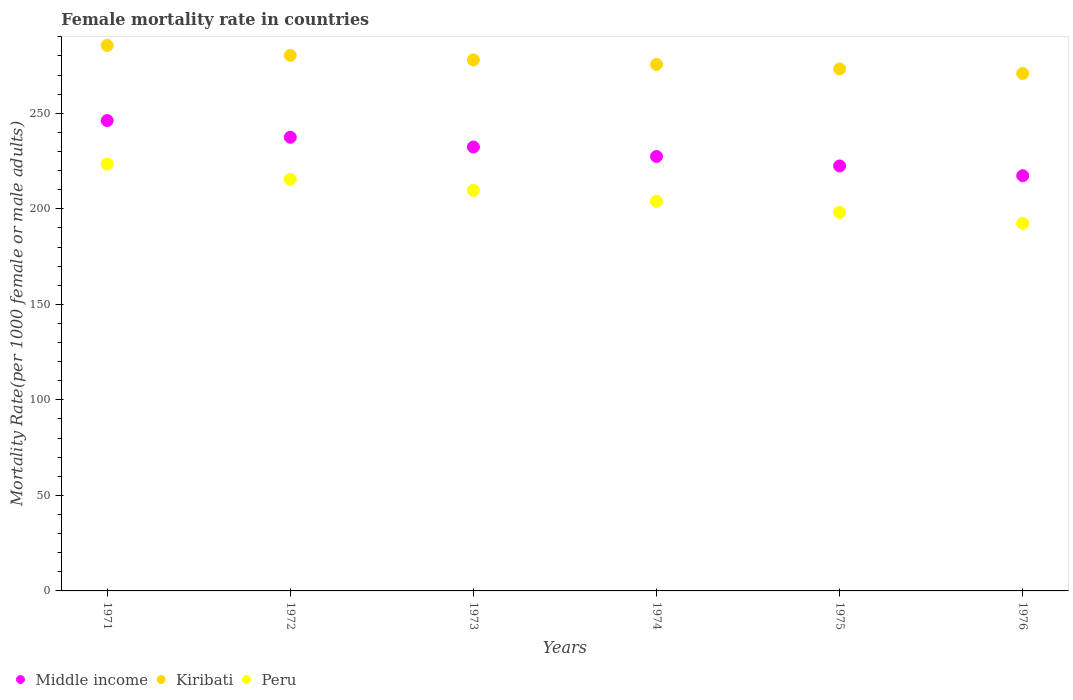How many different coloured dotlines are there?
Your answer should be very brief. 3. Is the number of dotlines equal to the number of legend labels?
Offer a very short reply. Yes. What is the female mortality rate in Peru in 1973?
Keep it short and to the point. 209.66. Across all years, what is the maximum female mortality rate in Kiribati?
Your response must be concise. 285.48. Across all years, what is the minimum female mortality rate in Kiribati?
Make the answer very short. 270.85. In which year was the female mortality rate in Kiribati maximum?
Ensure brevity in your answer.  1971. In which year was the female mortality rate in Peru minimum?
Offer a terse response. 1976. What is the total female mortality rate in Peru in the graph?
Your answer should be very brief. 1242.86. What is the difference between the female mortality rate in Middle income in 1974 and that in 1975?
Give a very brief answer. 4.95. What is the difference between the female mortality rate in Kiribati in 1973 and the female mortality rate in Middle income in 1974?
Make the answer very short. 50.55. What is the average female mortality rate in Kiribati per year?
Make the answer very short. 277.22. In the year 1974, what is the difference between the female mortality rate in Peru and female mortality rate in Middle income?
Provide a succinct answer. -23.49. What is the ratio of the female mortality rate in Kiribati in 1971 to that in 1974?
Your answer should be very brief. 1.04. What is the difference between the highest and the second highest female mortality rate in Kiribati?
Your response must be concise. 5.2. What is the difference between the highest and the lowest female mortality rate in Kiribati?
Offer a terse response. 14.63. In how many years, is the female mortality rate in Middle income greater than the average female mortality rate in Middle income taken over all years?
Provide a short and direct response. 3. Is it the case that in every year, the sum of the female mortality rate in Kiribati and female mortality rate in Middle income  is greater than the female mortality rate in Peru?
Make the answer very short. Yes. How many years are there in the graph?
Make the answer very short. 6. What is the difference between two consecutive major ticks on the Y-axis?
Ensure brevity in your answer.  50. Does the graph contain grids?
Give a very brief answer. No. Where does the legend appear in the graph?
Provide a short and direct response. Bottom left. How are the legend labels stacked?
Your response must be concise. Horizontal. What is the title of the graph?
Offer a very short reply. Female mortality rate in countries. Does "Mauritania" appear as one of the legend labels in the graph?
Keep it short and to the point. No. What is the label or title of the X-axis?
Offer a terse response. Years. What is the label or title of the Y-axis?
Offer a very short reply. Mortality Rate(per 1000 female or male adults). What is the Mortality Rate(per 1000 female or male adults) in Middle income in 1971?
Keep it short and to the point. 246.17. What is the Mortality Rate(per 1000 female or male adults) in Kiribati in 1971?
Your answer should be very brief. 285.48. What is the Mortality Rate(per 1000 female or male adults) of Peru in 1971?
Your answer should be very brief. 223.4. What is the Mortality Rate(per 1000 female or male adults) in Middle income in 1972?
Provide a short and direct response. 237.44. What is the Mortality Rate(per 1000 female or male adults) of Kiribati in 1972?
Make the answer very short. 280.28. What is the Mortality Rate(per 1000 female or male adults) of Peru in 1972?
Give a very brief answer. 215.43. What is the Mortality Rate(per 1000 female or male adults) in Middle income in 1973?
Give a very brief answer. 232.35. What is the Mortality Rate(per 1000 female or male adults) of Kiribati in 1973?
Your answer should be very brief. 277.92. What is the Mortality Rate(per 1000 female or male adults) in Peru in 1973?
Provide a short and direct response. 209.66. What is the Mortality Rate(per 1000 female or male adults) in Middle income in 1974?
Keep it short and to the point. 227.38. What is the Mortality Rate(per 1000 female or male adults) of Kiribati in 1974?
Provide a succinct answer. 275.56. What is the Mortality Rate(per 1000 female or male adults) of Peru in 1974?
Your answer should be very brief. 203.89. What is the Mortality Rate(per 1000 female or male adults) in Middle income in 1975?
Your answer should be compact. 222.43. What is the Mortality Rate(per 1000 female or male adults) in Kiribati in 1975?
Offer a very short reply. 273.21. What is the Mortality Rate(per 1000 female or male adults) of Peru in 1975?
Your response must be concise. 198.12. What is the Mortality Rate(per 1000 female or male adults) in Middle income in 1976?
Offer a terse response. 217.32. What is the Mortality Rate(per 1000 female or male adults) in Kiribati in 1976?
Your answer should be very brief. 270.85. What is the Mortality Rate(per 1000 female or male adults) of Peru in 1976?
Your answer should be very brief. 192.36. Across all years, what is the maximum Mortality Rate(per 1000 female or male adults) of Middle income?
Offer a very short reply. 246.17. Across all years, what is the maximum Mortality Rate(per 1000 female or male adults) of Kiribati?
Provide a succinct answer. 285.48. Across all years, what is the maximum Mortality Rate(per 1000 female or male adults) in Peru?
Offer a terse response. 223.4. Across all years, what is the minimum Mortality Rate(per 1000 female or male adults) in Middle income?
Offer a terse response. 217.32. Across all years, what is the minimum Mortality Rate(per 1000 female or male adults) in Kiribati?
Provide a succinct answer. 270.85. Across all years, what is the minimum Mortality Rate(per 1000 female or male adults) in Peru?
Provide a short and direct response. 192.36. What is the total Mortality Rate(per 1000 female or male adults) in Middle income in the graph?
Your answer should be compact. 1383.07. What is the total Mortality Rate(per 1000 female or male adults) of Kiribati in the graph?
Your answer should be very brief. 1663.3. What is the total Mortality Rate(per 1000 female or male adults) of Peru in the graph?
Ensure brevity in your answer.  1242.86. What is the difference between the Mortality Rate(per 1000 female or male adults) in Middle income in 1971 and that in 1972?
Make the answer very short. 8.73. What is the difference between the Mortality Rate(per 1000 female or male adults) in Kiribati in 1971 and that in 1972?
Your answer should be compact. 5.2. What is the difference between the Mortality Rate(per 1000 female or male adults) in Peru in 1971 and that in 1972?
Your answer should be very brief. 7.98. What is the difference between the Mortality Rate(per 1000 female or male adults) of Middle income in 1971 and that in 1973?
Ensure brevity in your answer.  13.82. What is the difference between the Mortality Rate(per 1000 female or male adults) of Kiribati in 1971 and that in 1973?
Make the answer very short. 7.56. What is the difference between the Mortality Rate(per 1000 female or male adults) in Peru in 1971 and that in 1973?
Offer a terse response. 13.74. What is the difference between the Mortality Rate(per 1000 female or male adults) in Middle income in 1971 and that in 1974?
Give a very brief answer. 18.79. What is the difference between the Mortality Rate(per 1000 female or male adults) in Kiribati in 1971 and that in 1974?
Offer a terse response. 9.91. What is the difference between the Mortality Rate(per 1000 female or male adults) in Peru in 1971 and that in 1974?
Provide a succinct answer. 19.51. What is the difference between the Mortality Rate(per 1000 female or male adults) in Middle income in 1971 and that in 1975?
Ensure brevity in your answer.  23.74. What is the difference between the Mortality Rate(per 1000 female or male adults) of Kiribati in 1971 and that in 1975?
Keep it short and to the point. 12.27. What is the difference between the Mortality Rate(per 1000 female or male adults) of Peru in 1971 and that in 1975?
Offer a very short reply. 25.28. What is the difference between the Mortality Rate(per 1000 female or male adults) in Middle income in 1971 and that in 1976?
Provide a succinct answer. 28.85. What is the difference between the Mortality Rate(per 1000 female or male adults) in Kiribati in 1971 and that in 1976?
Offer a very short reply. 14.63. What is the difference between the Mortality Rate(per 1000 female or male adults) of Peru in 1971 and that in 1976?
Provide a succinct answer. 31.05. What is the difference between the Mortality Rate(per 1000 female or male adults) of Middle income in 1972 and that in 1973?
Provide a succinct answer. 5.09. What is the difference between the Mortality Rate(per 1000 female or male adults) of Kiribati in 1972 and that in 1973?
Provide a short and direct response. 2.36. What is the difference between the Mortality Rate(per 1000 female or male adults) of Peru in 1972 and that in 1973?
Offer a terse response. 5.77. What is the difference between the Mortality Rate(per 1000 female or male adults) of Middle income in 1972 and that in 1974?
Keep it short and to the point. 10.06. What is the difference between the Mortality Rate(per 1000 female or male adults) in Kiribati in 1972 and that in 1974?
Keep it short and to the point. 4.72. What is the difference between the Mortality Rate(per 1000 female or male adults) in Peru in 1972 and that in 1974?
Your answer should be very brief. 11.54. What is the difference between the Mortality Rate(per 1000 female or male adults) of Middle income in 1972 and that in 1975?
Provide a short and direct response. 15.01. What is the difference between the Mortality Rate(per 1000 female or male adults) in Kiribati in 1972 and that in 1975?
Provide a succinct answer. 7.07. What is the difference between the Mortality Rate(per 1000 female or male adults) in Peru in 1972 and that in 1975?
Your response must be concise. 17.3. What is the difference between the Mortality Rate(per 1000 female or male adults) in Middle income in 1972 and that in 1976?
Provide a short and direct response. 20.12. What is the difference between the Mortality Rate(per 1000 female or male adults) of Kiribati in 1972 and that in 1976?
Your response must be concise. 9.43. What is the difference between the Mortality Rate(per 1000 female or male adults) in Peru in 1972 and that in 1976?
Offer a very short reply. 23.07. What is the difference between the Mortality Rate(per 1000 female or male adults) of Middle income in 1973 and that in 1974?
Provide a short and direct response. 4.97. What is the difference between the Mortality Rate(per 1000 female or male adults) in Kiribati in 1973 and that in 1974?
Your answer should be compact. 2.36. What is the difference between the Mortality Rate(per 1000 female or male adults) in Peru in 1973 and that in 1974?
Keep it short and to the point. 5.77. What is the difference between the Mortality Rate(per 1000 female or male adults) in Middle income in 1973 and that in 1975?
Make the answer very short. 9.92. What is the difference between the Mortality Rate(per 1000 female or male adults) in Kiribati in 1973 and that in 1975?
Give a very brief answer. 4.72. What is the difference between the Mortality Rate(per 1000 female or male adults) in Peru in 1973 and that in 1975?
Offer a very short reply. 11.53. What is the difference between the Mortality Rate(per 1000 female or male adults) in Middle income in 1973 and that in 1976?
Ensure brevity in your answer.  15.03. What is the difference between the Mortality Rate(per 1000 female or male adults) in Kiribati in 1973 and that in 1976?
Your answer should be compact. 7.07. What is the difference between the Mortality Rate(per 1000 female or male adults) in Peru in 1973 and that in 1976?
Provide a short and direct response. 17.3. What is the difference between the Mortality Rate(per 1000 female or male adults) in Middle income in 1974 and that in 1975?
Make the answer very short. 4.95. What is the difference between the Mortality Rate(per 1000 female or male adults) of Kiribati in 1974 and that in 1975?
Provide a short and direct response. 2.36. What is the difference between the Mortality Rate(per 1000 female or male adults) of Peru in 1974 and that in 1975?
Ensure brevity in your answer.  5.77. What is the difference between the Mortality Rate(per 1000 female or male adults) in Middle income in 1974 and that in 1976?
Offer a very short reply. 10.06. What is the difference between the Mortality Rate(per 1000 female or male adults) in Kiribati in 1974 and that in 1976?
Keep it short and to the point. 4.72. What is the difference between the Mortality Rate(per 1000 female or male adults) of Peru in 1974 and that in 1976?
Your response must be concise. 11.54. What is the difference between the Mortality Rate(per 1000 female or male adults) of Middle income in 1975 and that in 1976?
Ensure brevity in your answer.  5.11. What is the difference between the Mortality Rate(per 1000 female or male adults) of Kiribati in 1975 and that in 1976?
Ensure brevity in your answer.  2.36. What is the difference between the Mortality Rate(per 1000 female or male adults) of Peru in 1975 and that in 1976?
Ensure brevity in your answer.  5.77. What is the difference between the Mortality Rate(per 1000 female or male adults) of Middle income in 1971 and the Mortality Rate(per 1000 female or male adults) of Kiribati in 1972?
Your answer should be compact. -34.11. What is the difference between the Mortality Rate(per 1000 female or male adults) in Middle income in 1971 and the Mortality Rate(per 1000 female or male adults) in Peru in 1972?
Offer a very short reply. 30.74. What is the difference between the Mortality Rate(per 1000 female or male adults) of Kiribati in 1971 and the Mortality Rate(per 1000 female or male adults) of Peru in 1972?
Provide a short and direct response. 70.05. What is the difference between the Mortality Rate(per 1000 female or male adults) of Middle income in 1971 and the Mortality Rate(per 1000 female or male adults) of Kiribati in 1973?
Offer a terse response. -31.76. What is the difference between the Mortality Rate(per 1000 female or male adults) in Middle income in 1971 and the Mortality Rate(per 1000 female or male adults) in Peru in 1973?
Offer a terse response. 36.51. What is the difference between the Mortality Rate(per 1000 female or male adults) of Kiribati in 1971 and the Mortality Rate(per 1000 female or male adults) of Peru in 1973?
Provide a succinct answer. 75.82. What is the difference between the Mortality Rate(per 1000 female or male adults) of Middle income in 1971 and the Mortality Rate(per 1000 female or male adults) of Kiribati in 1974?
Offer a very short reply. -29.4. What is the difference between the Mortality Rate(per 1000 female or male adults) of Middle income in 1971 and the Mortality Rate(per 1000 female or male adults) of Peru in 1974?
Give a very brief answer. 42.28. What is the difference between the Mortality Rate(per 1000 female or male adults) in Kiribati in 1971 and the Mortality Rate(per 1000 female or male adults) in Peru in 1974?
Provide a short and direct response. 81.59. What is the difference between the Mortality Rate(per 1000 female or male adults) in Middle income in 1971 and the Mortality Rate(per 1000 female or male adults) in Kiribati in 1975?
Ensure brevity in your answer.  -27.04. What is the difference between the Mortality Rate(per 1000 female or male adults) in Middle income in 1971 and the Mortality Rate(per 1000 female or male adults) in Peru in 1975?
Your response must be concise. 48.04. What is the difference between the Mortality Rate(per 1000 female or male adults) in Kiribati in 1971 and the Mortality Rate(per 1000 female or male adults) in Peru in 1975?
Ensure brevity in your answer.  87.36. What is the difference between the Mortality Rate(per 1000 female or male adults) in Middle income in 1971 and the Mortality Rate(per 1000 female or male adults) in Kiribati in 1976?
Ensure brevity in your answer.  -24.68. What is the difference between the Mortality Rate(per 1000 female or male adults) of Middle income in 1971 and the Mortality Rate(per 1000 female or male adults) of Peru in 1976?
Provide a short and direct response. 53.81. What is the difference between the Mortality Rate(per 1000 female or male adults) in Kiribati in 1971 and the Mortality Rate(per 1000 female or male adults) in Peru in 1976?
Your answer should be very brief. 93.12. What is the difference between the Mortality Rate(per 1000 female or male adults) of Middle income in 1972 and the Mortality Rate(per 1000 female or male adults) of Kiribati in 1973?
Ensure brevity in your answer.  -40.48. What is the difference between the Mortality Rate(per 1000 female or male adults) of Middle income in 1972 and the Mortality Rate(per 1000 female or male adults) of Peru in 1973?
Ensure brevity in your answer.  27.78. What is the difference between the Mortality Rate(per 1000 female or male adults) in Kiribati in 1972 and the Mortality Rate(per 1000 female or male adults) in Peru in 1973?
Keep it short and to the point. 70.62. What is the difference between the Mortality Rate(per 1000 female or male adults) of Middle income in 1972 and the Mortality Rate(per 1000 female or male adults) of Kiribati in 1974?
Your answer should be very brief. -38.12. What is the difference between the Mortality Rate(per 1000 female or male adults) of Middle income in 1972 and the Mortality Rate(per 1000 female or male adults) of Peru in 1974?
Your answer should be very brief. 33.55. What is the difference between the Mortality Rate(per 1000 female or male adults) in Kiribati in 1972 and the Mortality Rate(per 1000 female or male adults) in Peru in 1974?
Offer a very short reply. 76.39. What is the difference between the Mortality Rate(per 1000 female or male adults) of Middle income in 1972 and the Mortality Rate(per 1000 female or male adults) of Kiribati in 1975?
Provide a succinct answer. -35.77. What is the difference between the Mortality Rate(per 1000 female or male adults) of Middle income in 1972 and the Mortality Rate(per 1000 female or male adults) of Peru in 1975?
Your answer should be very brief. 39.32. What is the difference between the Mortality Rate(per 1000 female or male adults) in Kiribati in 1972 and the Mortality Rate(per 1000 female or male adults) in Peru in 1975?
Your answer should be very brief. 82.16. What is the difference between the Mortality Rate(per 1000 female or male adults) in Middle income in 1972 and the Mortality Rate(per 1000 female or male adults) in Kiribati in 1976?
Make the answer very short. -33.41. What is the difference between the Mortality Rate(per 1000 female or male adults) in Middle income in 1972 and the Mortality Rate(per 1000 female or male adults) in Peru in 1976?
Give a very brief answer. 45.08. What is the difference between the Mortality Rate(per 1000 female or male adults) in Kiribati in 1972 and the Mortality Rate(per 1000 female or male adults) in Peru in 1976?
Provide a succinct answer. 87.92. What is the difference between the Mortality Rate(per 1000 female or male adults) in Middle income in 1973 and the Mortality Rate(per 1000 female or male adults) in Kiribati in 1974?
Keep it short and to the point. -43.22. What is the difference between the Mortality Rate(per 1000 female or male adults) of Middle income in 1973 and the Mortality Rate(per 1000 female or male adults) of Peru in 1974?
Your answer should be very brief. 28.46. What is the difference between the Mortality Rate(per 1000 female or male adults) in Kiribati in 1973 and the Mortality Rate(per 1000 female or male adults) in Peru in 1974?
Make the answer very short. 74.03. What is the difference between the Mortality Rate(per 1000 female or male adults) of Middle income in 1973 and the Mortality Rate(per 1000 female or male adults) of Kiribati in 1975?
Ensure brevity in your answer.  -40.86. What is the difference between the Mortality Rate(per 1000 female or male adults) in Middle income in 1973 and the Mortality Rate(per 1000 female or male adults) in Peru in 1975?
Ensure brevity in your answer.  34.22. What is the difference between the Mortality Rate(per 1000 female or male adults) in Kiribati in 1973 and the Mortality Rate(per 1000 female or male adults) in Peru in 1975?
Give a very brief answer. 79.8. What is the difference between the Mortality Rate(per 1000 female or male adults) of Middle income in 1973 and the Mortality Rate(per 1000 female or male adults) of Kiribati in 1976?
Make the answer very short. -38.5. What is the difference between the Mortality Rate(per 1000 female or male adults) of Middle income in 1973 and the Mortality Rate(per 1000 female or male adults) of Peru in 1976?
Offer a very short reply. 39.99. What is the difference between the Mortality Rate(per 1000 female or male adults) in Kiribati in 1973 and the Mortality Rate(per 1000 female or male adults) in Peru in 1976?
Provide a short and direct response. 85.57. What is the difference between the Mortality Rate(per 1000 female or male adults) of Middle income in 1974 and the Mortality Rate(per 1000 female or male adults) of Kiribati in 1975?
Offer a very short reply. -45.83. What is the difference between the Mortality Rate(per 1000 female or male adults) in Middle income in 1974 and the Mortality Rate(per 1000 female or male adults) in Peru in 1975?
Your response must be concise. 29.25. What is the difference between the Mortality Rate(per 1000 female or male adults) of Kiribati in 1974 and the Mortality Rate(per 1000 female or male adults) of Peru in 1975?
Ensure brevity in your answer.  77.44. What is the difference between the Mortality Rate(per 1000 female or male adults) in Middle income in 1974 and the Mortality Rate(per 1000 female or male adults) in Kiribati in 1976?
Provide a succinct answer. -43.47. What is the difference between the Mortality Rate(per 1000 female or male adults) in Middle income in 1974 and the Mortality Rate(per 1000 female or male adults) in Peru in 1976?
Your response must be concise. 35.02. What is the difference between the Mortality Rate(per 1000 female or male adults) of Kiribati in 1974 and the Mortality Rate(per 1000 female or male adults) of Peru in 1976?
Ensure brevity in your answer.  83.21. What is the difference between the Mortality Rate(per 1000 female or male adults) of Middle income in 1975 and the Mortality Rate(per 1000 female or male adults) of Kiribati in 1976?
Ensure brevity in your answer.  -48.42. What is the difference between the Mortality Rate(per 1000 female or male adults) of Middle income in 1975 and the Mortality Rate(per 1000 female or male adults) of Peru in 1976?
Offer a very short reply. 30.07. What is the difference between the Mortality Rate(per 1000 female or male adults) in Kiribati in 1975 and the Mortality Rate(per 1000 female or male adults) in Peru in 1976?
Your answer should be very brief. 80.85. What is the average Mortality Rate(per 1000 female or male adults) of Middle income per year?
Your response must be concise. 230.51. What is the average Mortality Rate(per 1000 female or male adults) in Kiribati per year?
Make the answer very short. 277.22. What is the average Mortality Rate(per 1000 female or male adults) in Peru per year?
Your answer should be very brief. 207.14. In the year 1971, what is the difference between the Mortality Rate(per 1000 female or male adults) in Middle income and Mortality Rate(per 1000 female or male adults) in Kiribati?
Give a very brief answer. -39.31. In the year 1971, what is the difference between the Mortality Rate(per 1000 female or male adults) in Middle income and Mortality Rate(per 1000 female or male adults) in Peru?
Make the answer very short. 22.76. In the year 1971, what is the difference between the Mortality Rate(per 1000 female or male adults) of Kiribati and Mortality Rate(per 1000 female or male adults) of Peru?
Ensure brevity in your answer.  62.08. In the year 1972, what is the difference between the Mortality Rate(per 1000 female or male adults) of Middle income and Mortality Rate(per 1000 female or male adults) of Kiribati?
Your answer should be very brief. -42.84. In the year 1972, what is the difference between the Mortality Rate(per 1000 female or male adults) of Middle income and Mortality Rate(per 1000 female or male adults) of Peru?
Offer a terse response. 22.01. In the year 1972, what is the difference between the Mortality Rate(per 1000 female or male adults) of Kiribati and Mortality Rate(per 1000 female or male adults) of Peru?
Your answer should be compact. 64.85. In the year 1973, what is the difference between the Mortality Rate(per 1000 female or male adults) of Middle income and Mortality Rate(per 1000 female or male adults) of Kiribati?
Make the answer very short. -45.57. In the year 1973, what is the difference between the Mortality Rate(per 1000 female or male adults) in Middle income and Mortality Rate(per 1000 female or male adults) in Peru?
Offer a very short reply. 22.69. In the year 1973, what is the difference between the Mortality Rate(per 1000 female or male adults) of Kiribati and Mortality Rate(per 1000 female or male adults) of Peru?
Your answer should be compact. 68.26. In the year 1974, what is the difference between the Mortality Rate(per 1000 female or male adults) of Middle income and Mortality Rate(per 1000 female or male adults) of Kiribati?
Offer a terse response. -48.19. In the year 1974, what is the difference between the Mortality Rate(per 1000 female or male adults) in Middle income and Mortality Rate(per 1000 female or male adults) in Peru?
Offer a terse response. 23.49. In the year 1974, what is the difference between the Mortality Rate(per 1000 female or male adults) of Kiribati and Mortality Rate(per 1000 female or male adults) of Peru?
Offer a very short reply. 71.67. In the year 1975, what is the difference between the Mortality Rate(per 1000 female or male adults) in Middle income and Mortality Rate(per 1000 female or male adults) in Kiribati?
Give a very brief answer. -50.78. In the year 1975, what is the difference between the Mortality Rate(per 1000 female or male adults) in Middle income and Mortality Rate(per 1000 female or male adults) in Peru?
Provide a succinct answer. 24.3. In the year 1975, what is the difference between the Mortality Rate(per 1000 female or male adults) of Kiribati and Mortality Rate(per 1000 female or male adults) of Peru?
Provide a succinct answer. 75.08. In the year 1976, what is the difference between the Mortality Rate(per 1000 female or male adults) in Middle income and Mortality Rate(per 1000 female or male adults) in Kiribati?
Provide a succinct answer. -53.53. In the year 1976, what is the difference between the Mortality Rate(per 1000 female or male adults) of Middle income and Mortality Rate(per 1000 female or male adults) of Peru?
Your answer should be very brief. 24.96. In the year 1976, what is the difference between the Mortality Rate(per 1000 female or male adults) of Kiribati and Mortality Rate(per 1000 female or male adults) of Peru?
Give a very brief answer. 78.49. What is the ratio of the Mortality Rate(per 1000 female or male adults) in Middle income in 1971 to that in 1972?
Your response must be concise. 1.04. What is the ratio of the Mortality Rate(per 1000 female or male adults) in Kiribati in 1971 to that in 1972?
Ensure brevity in your answer.  1.02. What is the ratio of the Mortality Rate(per 1000 female or male adults) in Middle income in 1971 to that in 1973?
Your answer should be very brief. 1.06. What is the ratio of the Mortality Rate(per 1000 female or male adults) of Kiribati in 1971 to that in 1973?
Offer a terse response. 1.03. What is the ratio of the Mortality Rate(per 1000 female or male adults) in Peru in 1971 to that in 1973?
Your response must be concise. 1.07. What is the ratio of the Mortality Rate(per 1000 female or male adults) in Middle income in 1971 to that in 1974?
Offer a very short reply. 1.08. What is the ratio of the Mortality Rate(per 1000 female or male adults) in Kiribati in 1971 to that in 1974?
Your answer should be very brief. 1.04. What is the ratio of the Mortality Rate(per 1000 female or male adults) in Peru in 1971 to that in 1974?
Ensure brevity in your answer.  1.1. What is the ratio of the Mortality Rate(per 1000 female or male adults) in Middle income in 1971 to that in 1975?
Your answer should be compact. 1.11. What is the ratio of the Mortality Rate(per 1000 female or male adults) of Kiribati in 1971 to that in 1975?
Keep it short and to the point. 1.04. What is the ratio of the Mortality Rate(per 1000 female or male adults) of Peru in 1971 to that in 1975?
Your response must be concise. 1.13. What is the ratio of the Mortality Rate(per 1000 female or male adults) in Middle income in 1971 to that in 1976?
Offer a very short reply. 1.13. What is the ratio of the Mortality Rate(per 1000 female or male adults) in Kiribati in 1971 to that in 1976?
Your response must be concise. 1.05. What is the ratio of the Mortality Rate(per 1000 female or male adults) in Peru in 1971 to that in 1976?
Provide a short and direct response. 1.16. What is the ratio of the Mortality Rate(per 1000 female or male adults) of Middle income in 1972 to that in 1973?
Make the answer very short. 1.02. What is the ratio of the Mortality Rate(per 1000 female or male adults) of Kiribati in 1972 to that in 1973?
Offer a very short reply. 1.01. What is the ratio of the Mortality Rate(per 1000 female or male adults) of Peru in 1972 to that in 1973?
Provide a succinct answer. 1.03. What is the ratio of the Mortality Rate(per 1000 female or male adults) of Middle income in 1972 to that in 1974?
Ensure brevity in your answer.  1.04. What is the ratio of the Mortality Rate(per 1000 female or male adults) of Kiribati in 1972 to that in 1974?
Keep it short and to the point. 1.02. What is the ratio of the Mortality Rate(per 1000 female or male adults) of Peru in 1972 to that in 1974?
Make the answer very short. 1.06. What is the ratio of the Mortality Rate(per 1000 female or male adults) of Middle income in 1972 to that in 1975?
Ensure brevity in your answer.  1.07. What is the ratio of the Mortality Rate(per 1000 female or male adults) of Kiribati in 1972 to that in 1975?
Provide a short and direct response. 1.03. What is the ratio of the Mortality Rate(per 1000 female or male adults) of Peru in 1972 to that in 1975?
Make the answer very short. 1.09. What is the ratio of the Mortality Rate(per 1000 female or male adults) of Middle income in 1972 to that in 1976?
Provide a succinct answer. 1.09. What is the ratio of the Mortality Rate(per 1000 female or male adults) of Kiribati in 1972 to that in 1976?
Provide a short and direct response. 1.03. What is the ratio of the Mortality Rate(per 1000 female or male adults) in Peru in 1972 to that in 1976?
Offer a very short reply. 1.12. What is the ratio of the Mortality Rate(per 1000 female or male adults) of Middle income in 1973 to that in 1974?
Provide a succinct answer. 1.02. What is the ratio of the Mortality Rate(per 1000 female or male adults) of Kiribati in 1973 to that in 1974?
Provide a short and direct response. 1.01. What is the ratio of the Mortality Rate(per 1000 female or male adults) of Peru in 1973 to that in 1974?
Your response must be concise. 1.03. What is the ratio of the Mortality Rate(per 1000 female or male adults) of Middle income in 1973 to that in 1975?
Offer a terse response. 1.04. What is the ratio of the Mortality Rate(per 1000 female or male adults) of Kiribati in 1973 to that in 1975?
Offer a very short reply. 1.02. What is the ratio of the Mortality Rate(per 1000 female or male adults) in Peru in 1973 to that in 1975?
Give a very brief answer. 1.06. What is the ratio of the Mortality Rate(per 1000 female or male adults) in Middle income in 1973 to that in 1976?
Ensure brevity in your answer.  1.07. What is the ratio of the Mortality Rate(per 1000 female or male adults) in Kiribati in 1973 to that in 1976?
Provide a short and direct response. 1.03. What is the ratio of the Mortality Rate(per 1000 female or male adults) of Peru in 1973 to that in 1976?
Offer a very short reply. 1.09. What is the ratio of the Mortality Rate(per 1000 female or male adults) of Middle income in 1974 to that in 1975?
Give a very brief answer. 1.02. What is the ratio of the Mortality Rate(per 1000 female or male adults) of Kiribati in 1974 to that in 1975?
Provide a succinct answer. 1.01. What is the ratio of the Mortality Rate(per 1000 female or male adults) in Peru in 1974 to that in 1975?
Give a very brief answer. 1.03. What is the ratio of the Mortality Rate(per 1000 female or male adults) in Middle income in 1974 to that in 1976?
Offer a terse response. 1.05. What is the ratio of the Mortality Rate(per 1000 female or male adults) in Kiribati in 1974 to that in 1976?
Your answer should be very brief. 1.02. What is the ratio of the Mortality Rate(per 1000 female or male adults) of Peru in 1974 to that in 1976?
Offer a very short reply. 1.06. What is the ratio of the Mortality Rate(per 1000 female or male adults) of Middle income in 1975 to that in 1976?
Offer a very short reply. 1.02. What is the ratio of the Mortality Rate(per 1000 female or male adults) in Kiribati in 1975 to that in 1976?
Your response must be concise. 1.01. What is the difference between the highest and the second highest Mortality Rate(per 1000 female or male adults) in Middle income?
Ensure brevity in your answer.  8.73. What is the difference between the highest and the second highest Mortality Rate(per 1000 female or male adults) in Kiribati?
Your answer should be compact. 5.2. What is the difference between the highest and the second highest Mortality Rate(per 1000 female or male adults) of Peru?
Provide a succinct answer. 7.98. What is the difference between the highest and the lowest Mortality Rate(per 1000 female or male adults) in Middle income?
Ensure brevity in your answer.  28.85. What is the difference between the highest and the lowest Mortality Rate(per 1000 female or male adults) of Kiribati?
Your response must be concise. 14.63. What is the difference between the highest and the lowest Mortality Rate(per 1000 female or male adults) in Peru?
Provide a succinct answer. 31.05. 